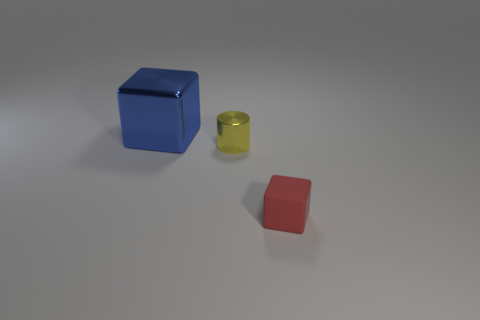Is there anything else that has the same size as the blue shiny cube?
Your response must be concise. No. How many blue shiny objects are in front of the block that is on the left side of the small thing that is in front of the yellow cylinder?
Provide a succinct answer. 0. What size is the blue block that is made of the same material as the small yellow thing?
Provide a short and direct response. Large. There is a block on the left side of the red cube; does it have the same size as the small yellow cylinder?
Provide a short and direct response. No. What is the color of the object that is to the right of the blue metallic block and on the left side of the rubber cube?
Keep it short and to the point. Yellow. What number of objects are yellow things or small metallic things behind the small rubber thing?
Make the answer very short. 1. What material is the block that is right of the cube that is to the left of the block right of the large blue shiny object?
Keep it short and to the point. Rubber. Is there any other thing that has the same material as the tiny red cube?
Provide a short and direct response. No. How many gray things are small cubes or shiny cylinders?
Ensure brevity in your answer.  0. What number of other objects are the same shape as the yellow metal thing?
Provide a short and direct response. 0. 